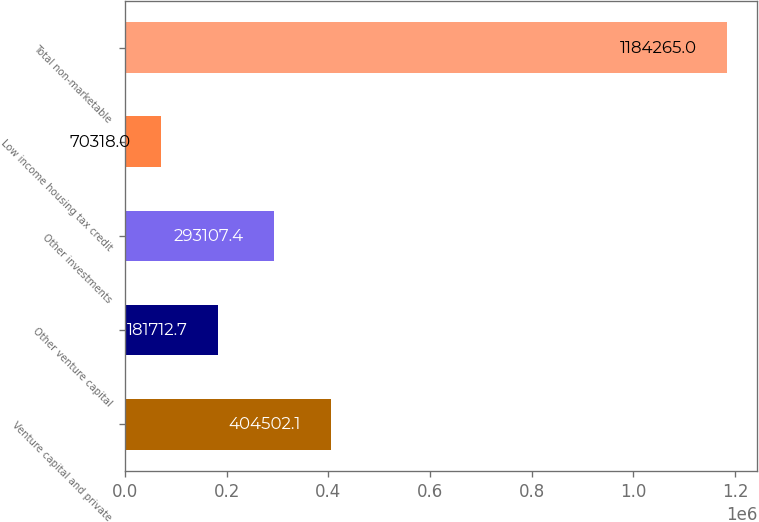Convert chart to OTSL. <chart><loc_0><loc_0><loc_500><loc_500><bar_chart><fcel>Venture capital and private<fcel>Other venture capital<fcel>Other investments<fcel>Low income housing tax credit<fcel>Total non-marketable<nl><fcel>404502<fcel>181713<fcel>293107<fcel>70318<fcel>1.18426e+06<nl></chart> 